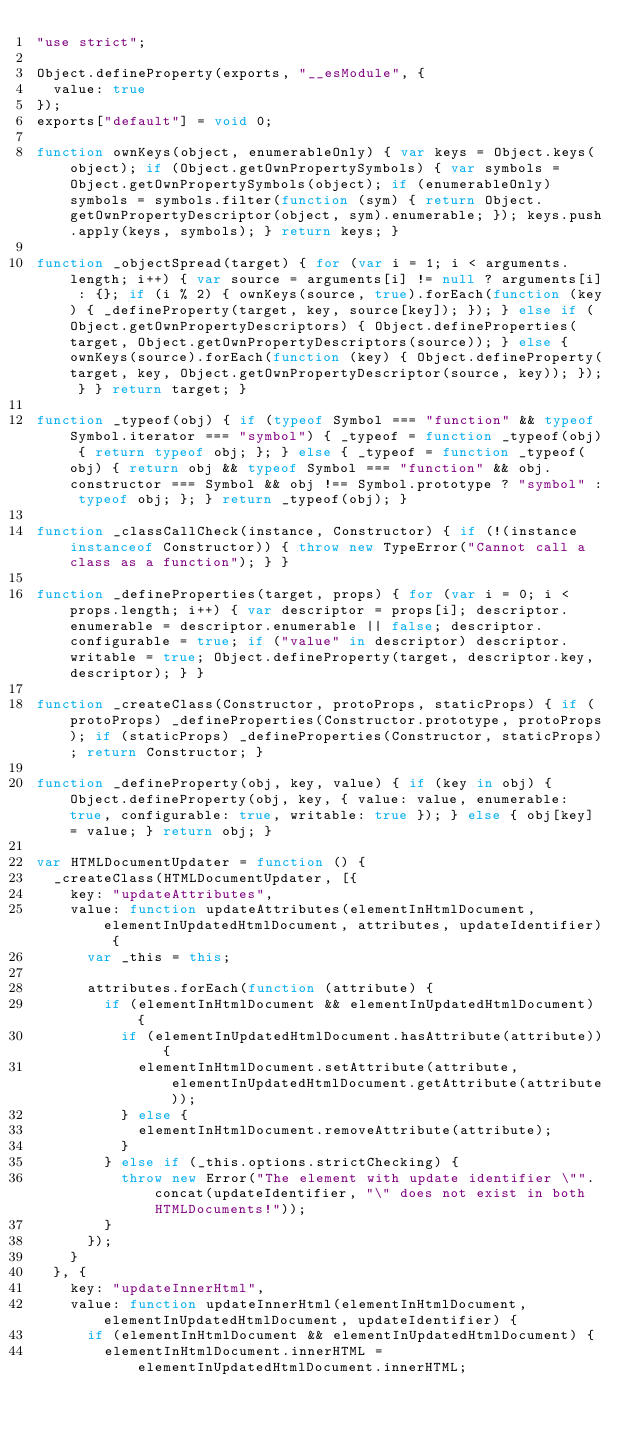<code> <loc_0><loc_0><loc_500><loc_500><_JavaScript_>"use strict";

Object.defineProperty(exports, "__esModule", {
  value: true
});
exports["default"] = void 0;

function ownKeys(object, enumerableOnly) { var keys = Object.keys(object); if (Object.getOwnPropertySymbols) { var symbols = Object.getOwnPropertySymbols(object); if (enumerableOnly) symbols = symbols.filter(function (sym) { return Object.getOwnPropertyDescriptor(object, sym).enumerable; }); keys.push.apply(keys, symbols); } return keys; }

function _objectSpread(target) { for (var i = 1; i < arguments.length; i++) { var source = arguments[i] != null ? arguments[i] : {}; if (i % 2) { ownKeys(source, true).forEach(function (key) { _defineProperty(target, key, source[key]); }); } else if (Object.getOwnPropertyDescriptors) { Object.defineProperties(target, Object.getOwnPropertyDescriptors(source)); } else { ownKeys(source).forEach(function (key) { Object.defineProperty(target, key, Object.getOwnPropertyDescriptor(source, key)); }); } } return target; }

function _typeof(obj) { if (typeof Symbol === "function" && typeof Symbol.iterator === "symbol") { _typeof = function _typeof(obj) { return typeof obj; }; } else { _typeof = function _typeof(obj) { return obj && typeof Symbol === "function" && obj.constructor === Symbol && obj !== Symbol.prototype ? "symbol" : typeof obj; }; } return _typeof(obj); }

function _classCallCheck(instance, Constructor) { if (!(instance instanceof Constructor)) { throw new TypeError("Cannot call a class as a function"); } }

function _defineProperties(target, props) { for (var i = 0; i < props.length; i++) { var descriptor = props[i]; descriptor.enumerable = descriptor.enumerable || false; descriptor.configurable = true; if ("value" in descriptor) descriptor.writable = true; Object.defineProperty(target, descriptor.key, descriptor); } }

function _createClass(Constructor, protoProps, staticProps) { if (protoProps) _defineProperties(Constructor.prototype, protoProps); if (staticProps) _defineProperties(Constructor, staticProps); return Constructor; }

function _defineProperty(obj, key, value) { if (key in obj) { Object.defineProperty(obj, key, { value: value, enumerable: true, configurable: true, writable: true }); } else { obj[key] = value; } return obj; }

var HTMLDocumentUpdater = function () {
  _createClass(HTMLDocumentUpdater, [{
    key: "updateAttributes",
    value: function updateAttributes(elementInHtmlDocument, elementInUpdatedHtmlDocument, attributes, updateIdentifier) {
      var _this = this;

      attributes.forEach(function (attribute) {
        if (elementInHtmlDocument && elementInUpdatedHtmlDocument) {
          if (elementInUpdatedHtmlDocument.hasAttribute(attribute)) {
            elementInHtmlDocument.setAttribute(attribute, elementInUpdatedHtmlDocument.getAttribute(attribute));
          } else {
            elementInHtmlDocument.removeAttribute(attribute);
          }
        } else if (_this.options.strictChecking) {
          throw new Error("The element with update identifier \"".concat(updateIdentifier, "\" does not exist in both HTMLDocuments!"));
        }
      });
    }
  }, {
    key: "updateInnerHtml",
    value: function updateInnerHtml(elementInHtmlDocument, elementInUpdatedHtmlDocument, updateIdentifier) {
      if (elementInHtmlDocument && elementInUpdatedHtmlDocument) {
        elementInHtmlDocument.innerHTML = elementInUpdatedHtmlDocument.innerHTML;</code> 